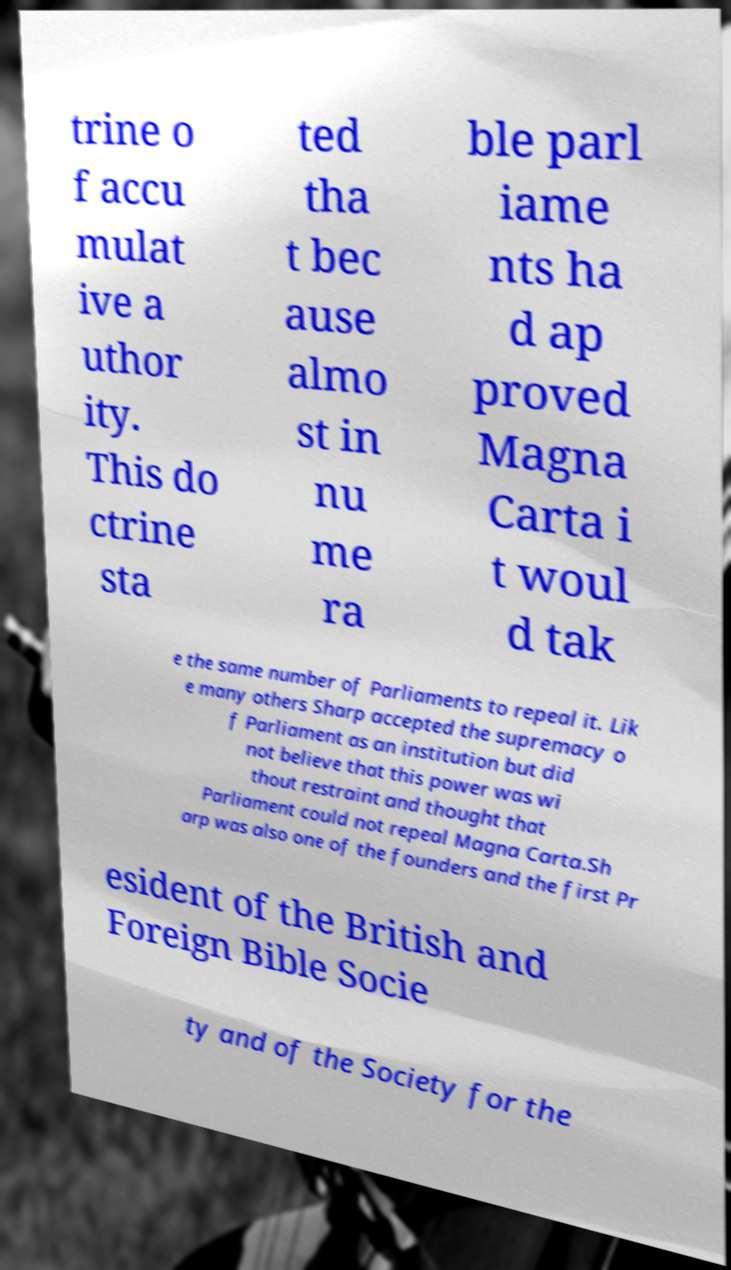What messages or text are displayed in this image? I need them in a readable, typed format. trine o f accu mulat ive a uthor ity. This do ctrine sta ted tha t bec ause almo st in nu me ra ble parl iame nts ha d ap proved Magna Carta i t woul d tak e the same number of Parliaments to repeal it. Lik e many others Sharp accepted the supremacy o f Parliament as an institution but did not believe that this power was wi thout restraint and thought that Parliament could not repeal Magna Carta.Sh arp was also one of the founders and the first Pr esident of the British and Foreign Bible Socie ty and of the Society for the 